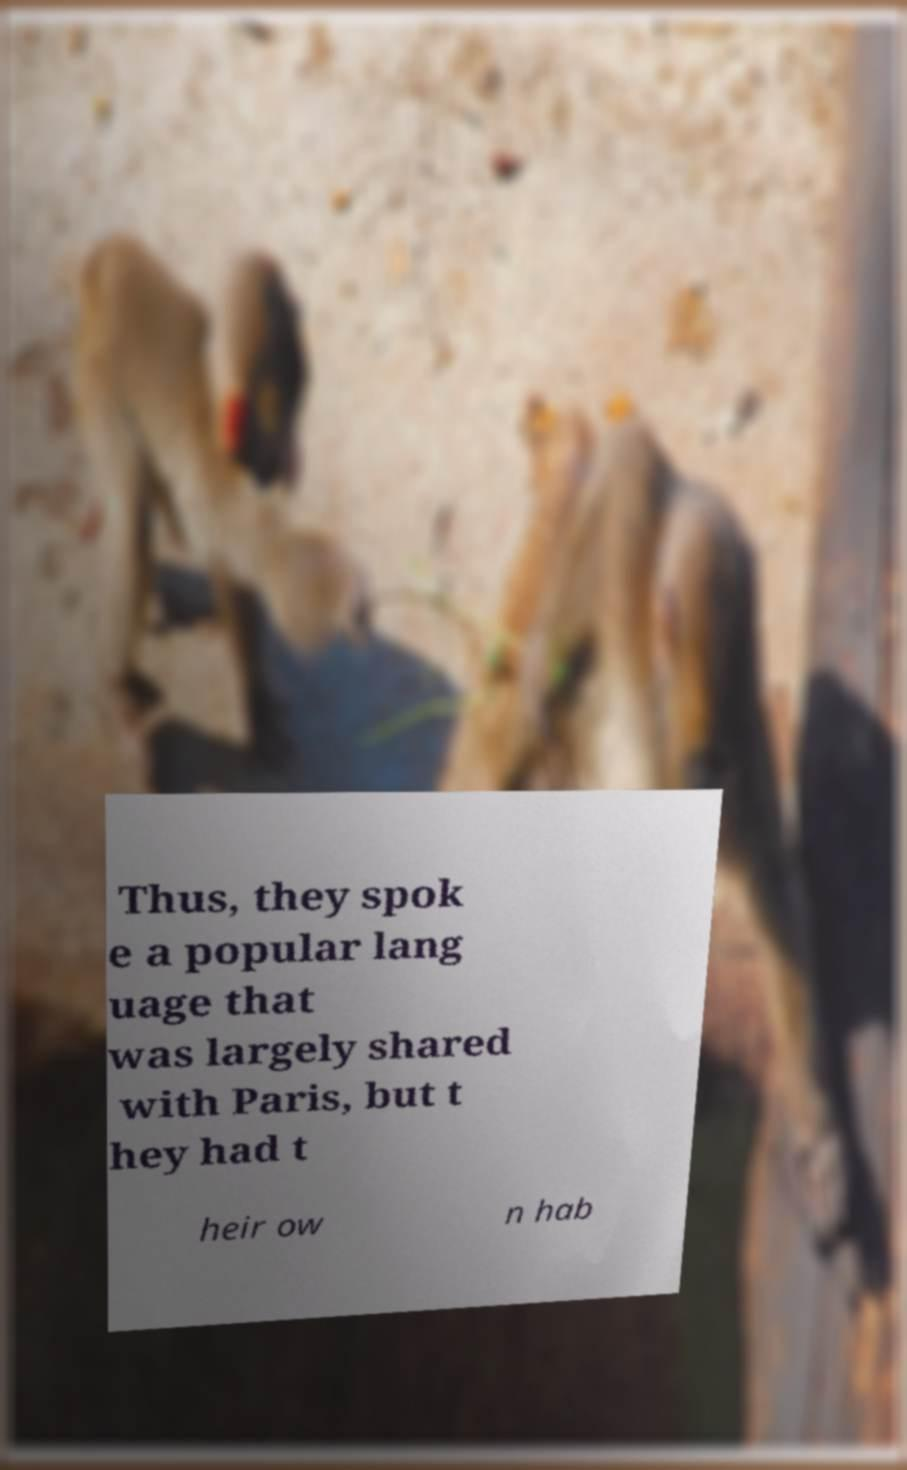For documentation purposes, I need the text within this image transcribed. Could you provide that? Thus, they spok e a popular lang uage that was largely shared with Paris, but t hey had t heir ow n hab 